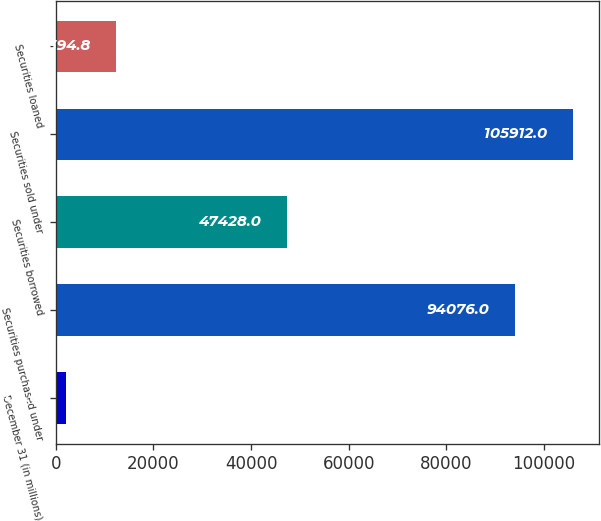<chart> <loc_0><loc_0><loc_500><loc_500><bar_chart><fcel>December 31 (in millions)<fcel>Securities purchased under<fcel>Securities borrowed<fcel>Securities sold under<fcel>Securities loaned<nl><fcel>2004<fcel>94076<fcel>47428<fcel>105912<fcel>12394.8<nl></chart> 